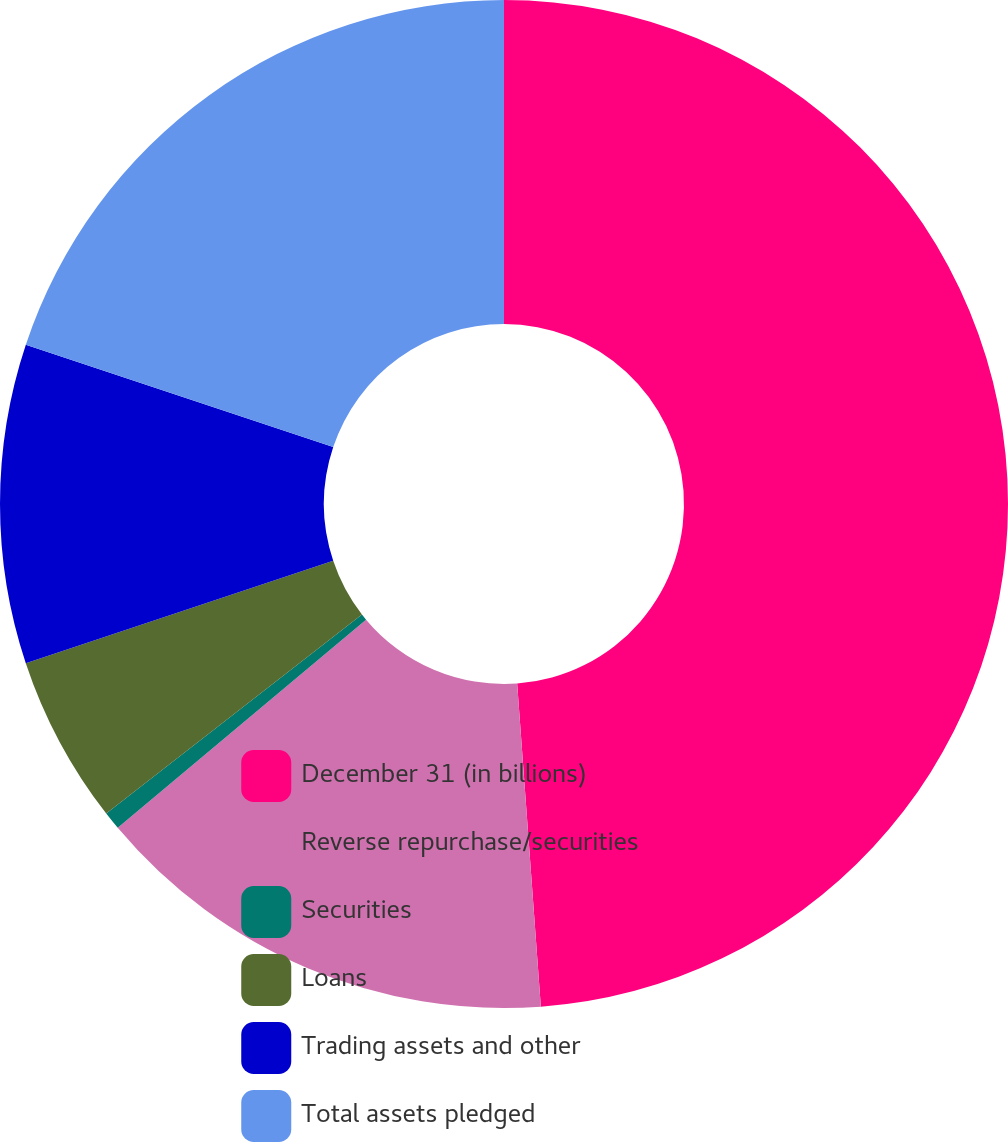<chart> <loc_0><loc_0><loc_500><loc_500><pie_chart><fcel>December 31 (in billions)<fcel>Reverse repurchase/securities<fcel>Securities<fcel>Loans<fcel>Trading assets and other<fcel>Total assets pledged<nl><fcel>48.83%<fcel>15.06%<fcel>0.58%<fcel>5.41%<fcel>10.23%<fcel>19.88%<nl></chart> 